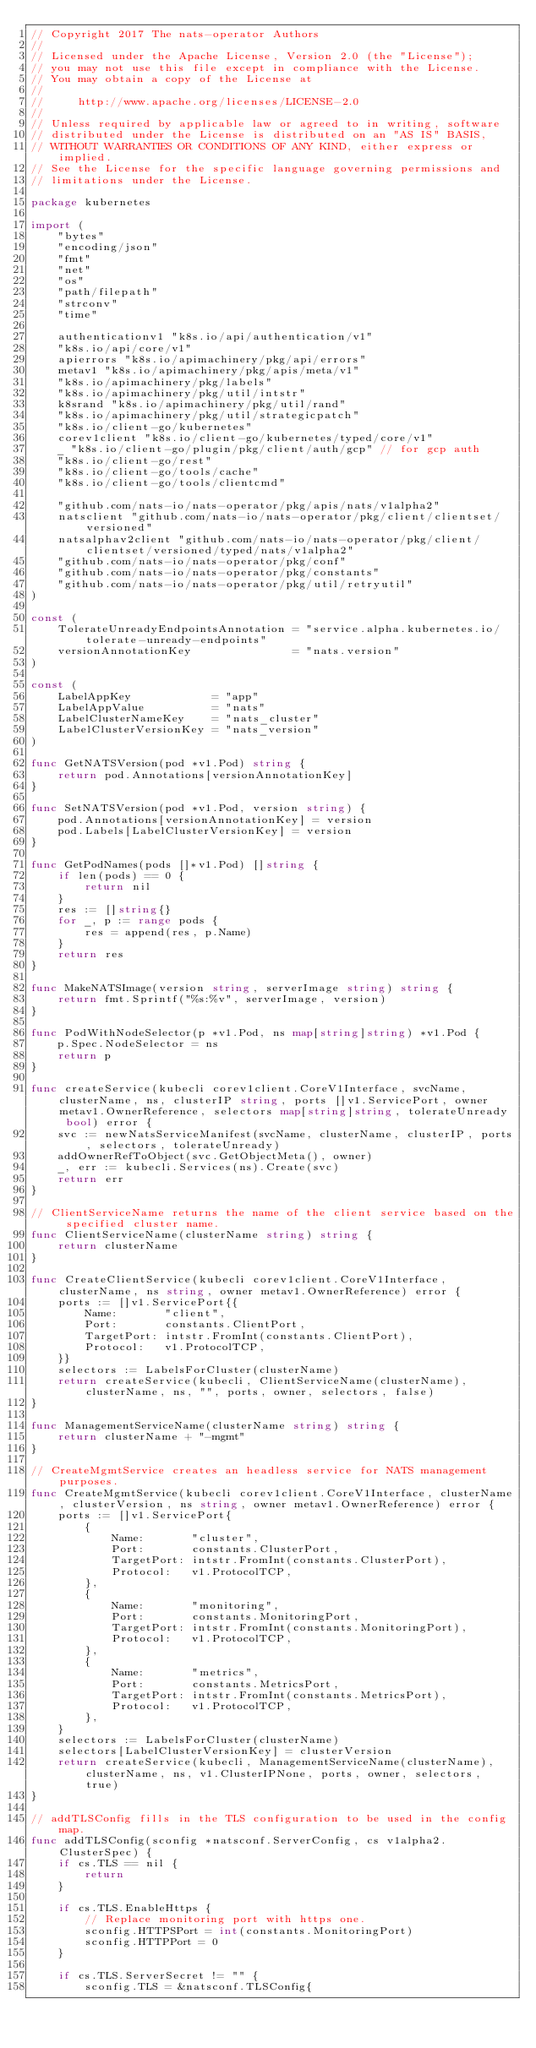<code> <loc_0><loc_0><loc_500><loc_500><_Go_>// Copyright 2017 The nats-operator Authors
//
// Licensed under the Apache License, Version 2.0 (the "License");
// you may not use this file except in compliance with the License.
// You may obtain a copy of the License at
//
//     http://www.apache.org/licenses/LICENSE-2.0
//
// Unless required by applicable law or agreed to in writing, software
// distributed under the License is distributed on an "AS IS" BASIS,
// WITHOUT WARRANTIES OR CONDITIONS OF ANY KIND, either express or implied.
// See the License for the specific language governing permissions and
// limitations under the License.

package kubernetes

import (
	"bytes"
	"encoding/json"
	"fmt"
	"net"
	"os"
	"path/filepath"
	"strconv"
	"time"

	authenticationv1 "k8s.io/api/authentication/v1"
	"k8s.io/api/core/v1"
	apierrors "k8s.io/apimachinery/pkg/api/errors"
	metav1 "k8s.io/apimachinery/pkg/apis/meta/v1"
	"k8s.io/apimachinery/pkg/labels"
	"k8s.io/apimachinery/pkg/util/intstr"
	k8srand "k8s.io/apimachinery/pkg/util/rand"
	"k8s.io/apimachinery/pkg/util/strategicpatch"
	"k8s.io/client-go/kubernetes"
	corev1client "k8s.io/client-go/kubernetes/typed/core/v1"
	_ "k8s.io/client-go/plugin/pkg/client/auth/gcp" // for gcp auth
	"k8s.io/client-go/rest"
	"k8s.io/client-go/tools/cache"
	"k8s.io/client-go/tools/clientcmd"

	"github.com/nats-io/nats-operator/pkg/apis/nats/v1alpha2"
	natsclient "github.com/nats-io/nats-operator/pkg/client/clientset/versioned"
	natsalphav2client "github.com/nats-io/nats-operator/pkg/client/clientset/versioned/typed/nats/v1alpha2"
	"github.com/nats-io/nats-operator/pkg/conf"
	"github.com/nats-io/nats-operator/pkg/constants"
	"github.com/nats-io/nats-operator/pkg/util/retryutil"
)

const (
	TolerateUnreadyEndpointsAnnotation = "service.alpha.kubernetes.io/tolerate-unready-endpoints"
	versionAnnotationKey               = "nats.version"
)

const (
	LabelAppKey            = "app"
	LabelAppValue          = "nats"
	LabelClusterNameKey    = "nats_cluster"
	LabelClusterVersionKey = "nats_version"
)

func GetNATSVersion(pod *v1.Pod) string {
	return pod.Annotations[versionAnnotationKey]
}

func SetNATSVersion(pod *v1.Pod, version string) {
	pod.Annotations[versionAnnotationKey] = version
	pod.Labels[LabelClusterVersionKey] = version
}

func GetPodNames(pods []*v1.Pod) []string {
	if len(pods) == 0 {
		return nil
	}
	res := []string{}
	for _, p := range pods {
		res = append(res, p.Name)
	}
	return res
}

func MakeNATSImage(version string, serverImage string) string {
	return fmt.Sprintf("%s:%v", serverImage, version)
}

func PodWithNodeSelector(p *v1.Pod, ns map[string]string) *v1.Pod {
	p.Spec.NodeSelector = ns
	return p
}

func createService(kubecli corev1client.CoreV1Interface, svcName, clusterName, ns, clusterIP string, ports []v1.ServicePort, owner metav1.OwnerReference, selectors map[string]string, tolerateUnready bool) error {
	svc := newNatsServiceManifest(svcName, clusterName, clusterIP, ports, selectors, tolerateUnready)
	addOwnerRefToObject(svc.GetObjectMeta(), owner)
	_, err := kubecli.Services(ns).Create(svc)
	return err
}

// ClientServiceName returns the name of the client service based on the specified cluster name.
func ClientServiceName(clusterName string) string {
	return clusterName
}

func CreateClientService(kubecli corev1client.CoreV1Interface, clusterName, ns string, owner metav1.OwnerReference) error {
	ports := []v1.ServicePort{{
		Name:       "client",
		Port:       constants.ClientPort,
		TargetPort: intstr.FromInt(constants.ClientPort),
		Protocol:   v1.ProtocolTCP,
	}}
	selectors := LabelsForCluster(clusterName)
	return createService(kubecli, ClientServiceName(clusterName), clusterName, ns, "", ports, owner, selectors, false)
}

func ManagementServiceName(clusterName string) string {
	return clusterName + "-mgmt"
}

// CreateMgmtService creates an headless service for NATS management purposes.
func CreateMgmtService(kubecli corev1client.CoreV1Interface, clusterName, clusterVersion, ns string, owner metav1.OwnerReference) error {
	ports := []v1.ServicePort{
		{
			Name:       "cluster",
			Port:       constants.ClusterPort,
			TargetPort: intstr.FromInt(constants.ClusterPort),
			Protocol:   v1.ProtocolTCP,
		},
		{
			Name:       "monitoring",
			Port:       constants.MonitoringPort,
			TargetPort: intstr.FromInt(constants.MonitoringPort),
			Protocol:   v1.ProtocolTCP,
		},
		{
			Name:       "metrics",
			Port:       constants.MetricsPort,
			TargetPort: intstr.FromInt(constants.MetricsPort),
			Protocol:   v1.ProtocolTCP,
		},
	}
	selectors := LabelsForCluster(clusterName)
	selectors[LabelClusterVersionKey] = clusterVersion
	return createService(kubecli, ManagementServiceName(clusterName), clusterName, ns, v1.ClusterIPNone, ports, owner, selectors, true)
}

// addTLSConfig fills in the TLS configuration to be used in the config map.
func addTLSConfig(sconfig *natsconf.ServerConfig, cs v1alpha2.ClusterSpec) {
	if cs.TLS == nil {
		return
	}

	if cs.TLS.EnableHttps {
		// Replace monitoring port with https one.
		sconfig.HTTPSPort = int(constants.MonitoringPort)
		sconfig.HTTPPort = 0
	}

	if cs.TLS.ServerSecret != "" {
		sconfig.TLS = &natsconf.TLSConfig{</code> 